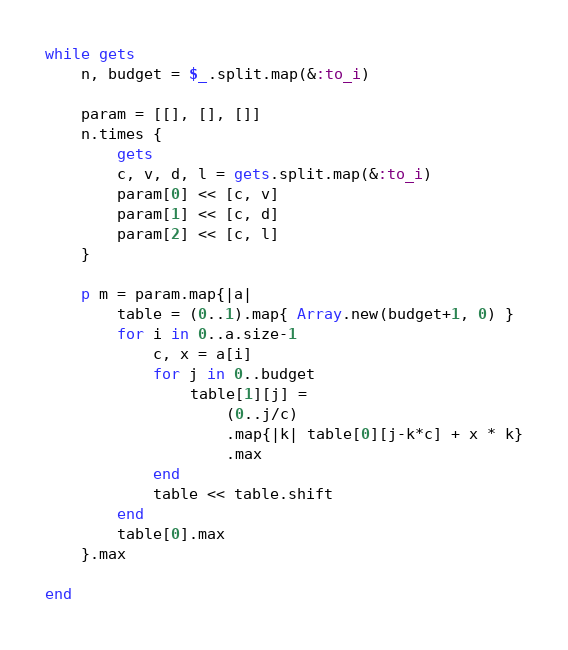<code> <loc_0><loc_0><loc_500><loc_500><_Ruby_>while gets
	n, budget = $_.split.map(&:to_i)
	
	param = [[], [], []]
	n.times {
		gets
		c, v, d, l = gets.split.map(&:to_i)
		param[0] << [c, v]
		param[1] << [c, d]
		param[2] << [c, l]
	}

	p m = param.map{|a|
		table = (0..1).map{ Array.new(budget+1, 0) }
		for i in 0..a.size-1
			c, x = a[i]
			for j in 0..budget
				table[1][j] = 
					(0..j/c)
					.map{|k| table[0][j-k*c] + x * k}
					.max
			end
			table << table.shift
		end
	 	table[0].max
	}.max

end</code> 